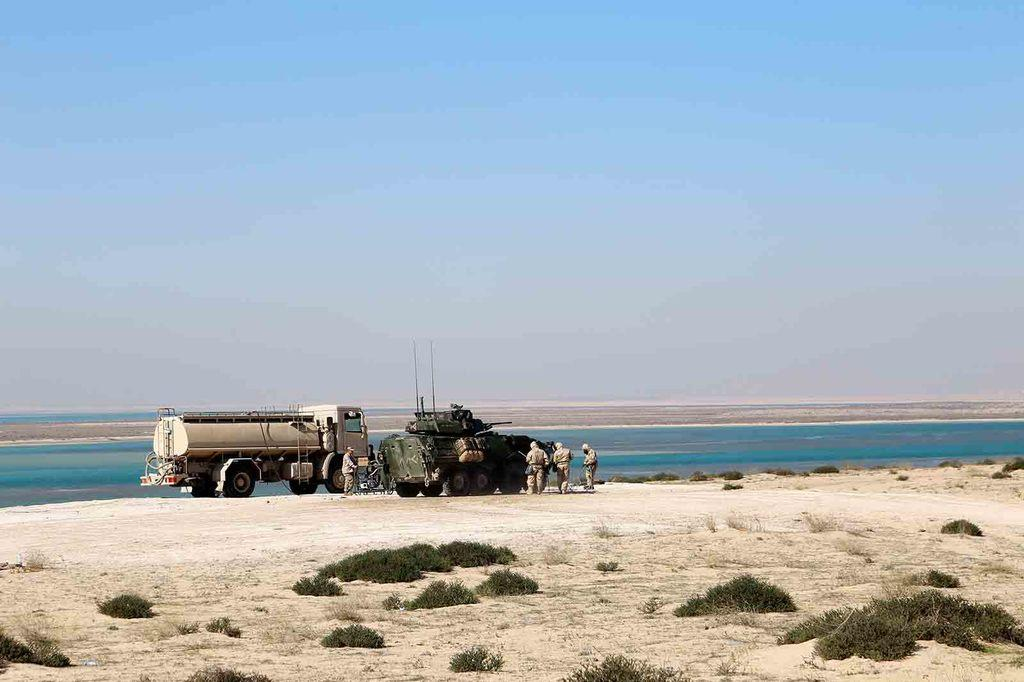What types of objects can be seen in the image? There are vehicles, plants, and people visible in the image. What natural element is present in the image? There is water visible in the image. What can be seen in the background of the image? The sky is visible in the background of the image. What type of cork can be seen floating in the water in the image? There is no cork present in the image; it only features vehicles, plants, people, water, and the sky. Can you describe the coastline visible in the image? There is no coastline visible in the image; it only features vehicles, plants, people, water, and the sky. 